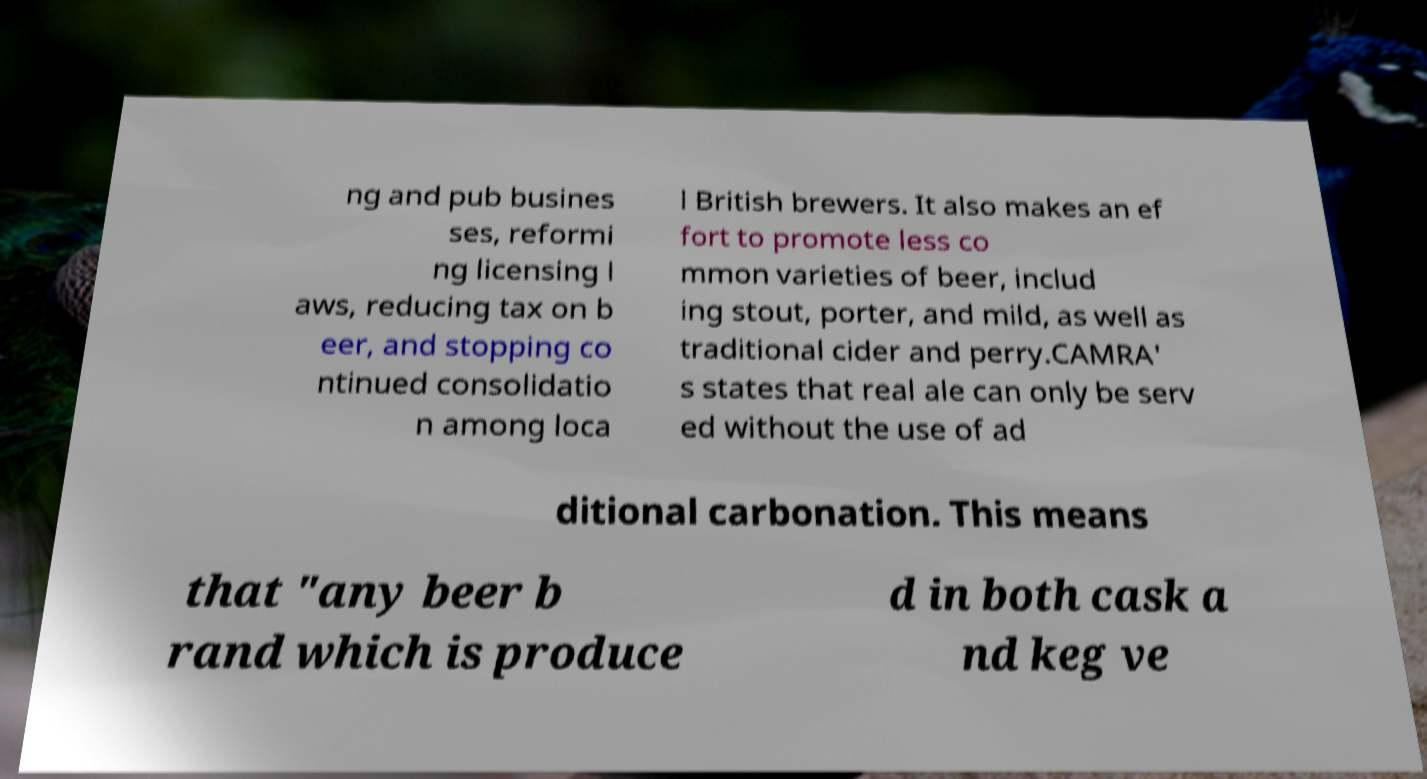What messages or text are displayed in this image? I need them in a readable, typed format. ng and pub busines ses, reformi ng licensing l aws, reducing tax on b eer, and stopping co ntinued consolidatio n among loca l British brewers. It also makes an ef fort to promote less co mmon varieties of beer, includ ing stout, porter, and mild, as well as traditional cider and perry.CAMRA' s states that real ale can only be serv ed without the use of ad ditional carbonation. This means that "any beer b rand which is produce d in both cask a nd keg ve 